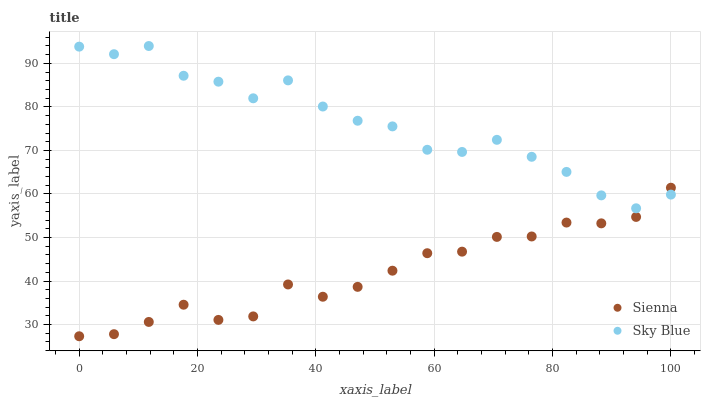Does Sienna have the minimum area under the curve?
Answer yes or no. Yes. Does Sky Blue have the maximum area under the curve?
Answer yes or no. Yes. Does Sky Blue have the minimum area under the curve?
Answer yes or no. No. Is Sienna the smoothest?
Answer yes or no. Yes. Is Sky Blue the roughest?
Answer yes or no. Yes. Is Sky Blue the smoothest?
Answer yes or no. No. Does Sienna have the lowest value?
Answer yes or no. Yes. Does Sky Blue have the lowest value?
Answer yes or no. No. Does Sky Blue have the highest value?
Answer yes or no. Yes. Does Sienna intersect Sky Blue?
Answer yes or no. Yes. Is Sienna less than Sky Blue?
Answer yes or no. No. Is Sienna greater than Sky Blue?
Answer yes or no. No. 